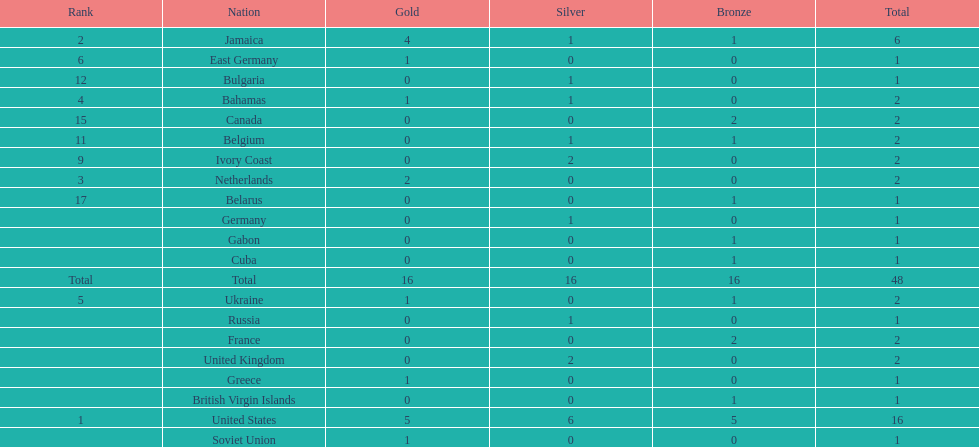What is the average number of gold medals won by the top 5 nations? 2.6. 